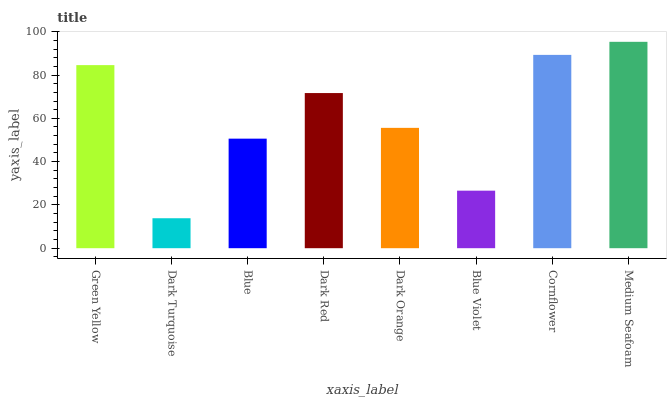Is Dark Turquoise the minimum?
Answer yes or no. Yes. Is Medium Seafoam the maximum?
Answer yes or no. Yes. Is Blue the minimum?
Answer yes or no. No. Is Blue the maximum?
Answer yes or no. No. Is Blue greater than Dark Turquoise?
Answer yes or no. Yes. Is Dark Turquoise less than Blue?
Answer yes or no. Yes. Is Dark Turquoise greater than Blue?
Answer yes or no. No. Is Blue less than Dark Turquoise?
Answer yes or no. No. Is Dark Red the high median?
Answer yes or no. Yes. Is Dark Orange the low median?
Answer yes or no. Yes. Is Cornflower the high median?
Answer yes or no. No. Is Dark Red the low median?
Answer yes or no. No. 